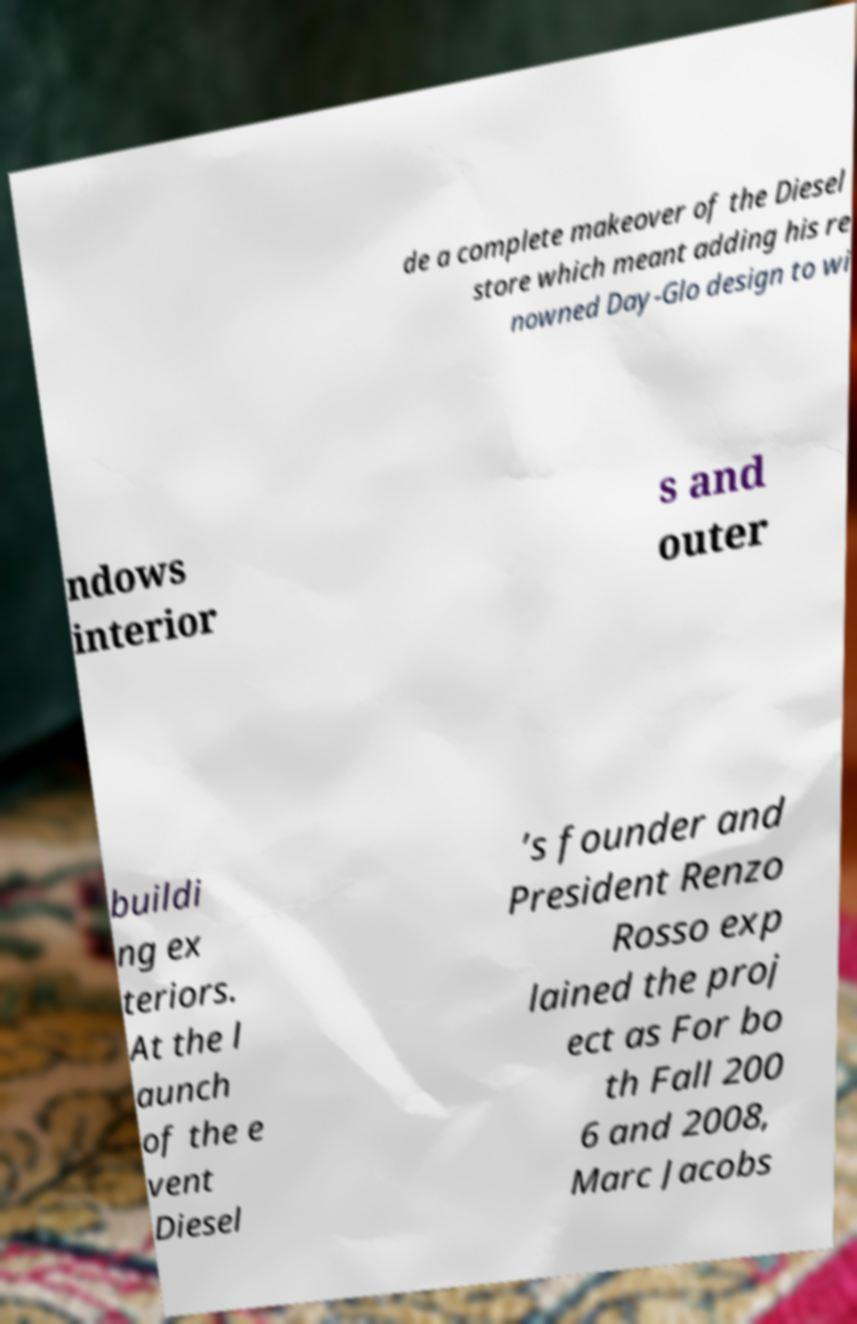For documentation purposes, I need the text within this image transcribed. Could you provide that? de a complete makeover of the Diesel store which meant adding his re nowned Day-Glo design to wi ndows interior s and outer buildi ng ex teriors. At the l aunch of the e vent Diesel ’s founder and President Renzo Rosso exp lained the proj ect as For bo th Fall 200 6 and 2008, Marc Jacobs 